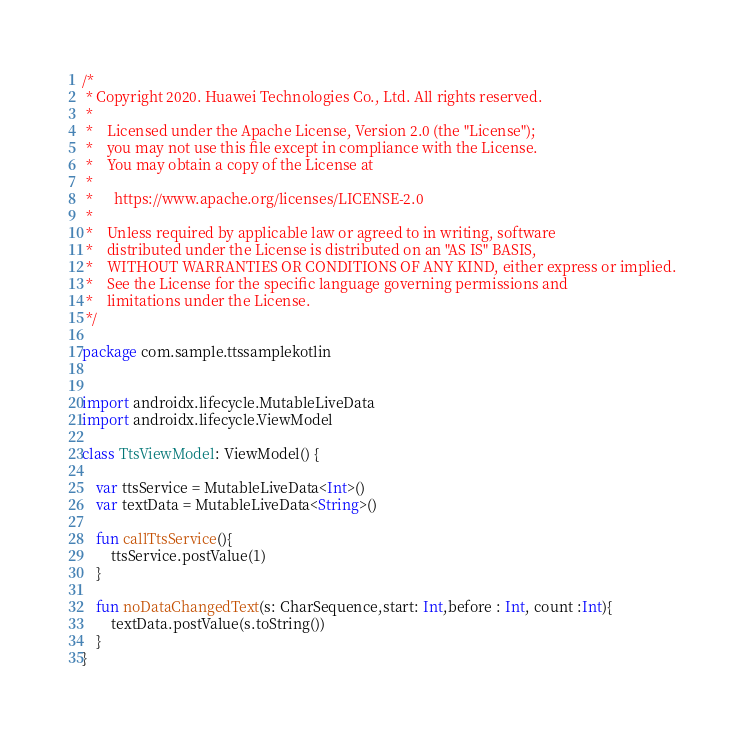Convert code to text. <code><loc_0><loc_0><loc_500><loc_500><_Kotlin_>/*
 * Copyright 2020. Huawei Technologies Co., Ltd. All rights reserved.
 *
 *    Licensed under the Apache License, Version 2.0 (the "License");
 *    you may not use this file except in compliance with the License.
 *    You may obtain a copy of the License at
 *
 *      https://www.apache.org/licenses/LICENSE-2.0
 *
 *    Unless required by applicable law or agreed to in writing, software
 *    distributed under the License is distributed on an "AS IS" BASIS,
 *    WITHOUT WARRANTIES OR CONDITIONS OF ANY KIND, either express or implied.
 *    See the License for the specific language governing permissions and
 *    limitations under the License.
 */

package com.sample.ttssamplekotlin


import androidx.lifecycle.MutableLiveData
import androidx.lifecycle.ViewModel

class TtsViewModel: ViewModel() {

    var ttsService = MutableLiveData<Int>()
    var textData = MutableLiveData<String>()

    fun callTtsService(){
        ttsService.postValue(1)
    }

    fun noDataChangedText(s: CharSequence,start: Int,before : Int, count :Int){
        textData.postValue(s.toString())
    }
}</code> 